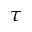<formula> <loc_0><loc_0><loc_500><loc_500>\tau</formula> 